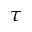<formula> <loc_0><loc_0><loc_500><loc_500>\tau</formula> 